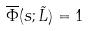<formula> <loc_0><loc_0><loc_500><loc_500>\overline { \Phi } ( s ; \tilde { L } ) = 1</formula> 